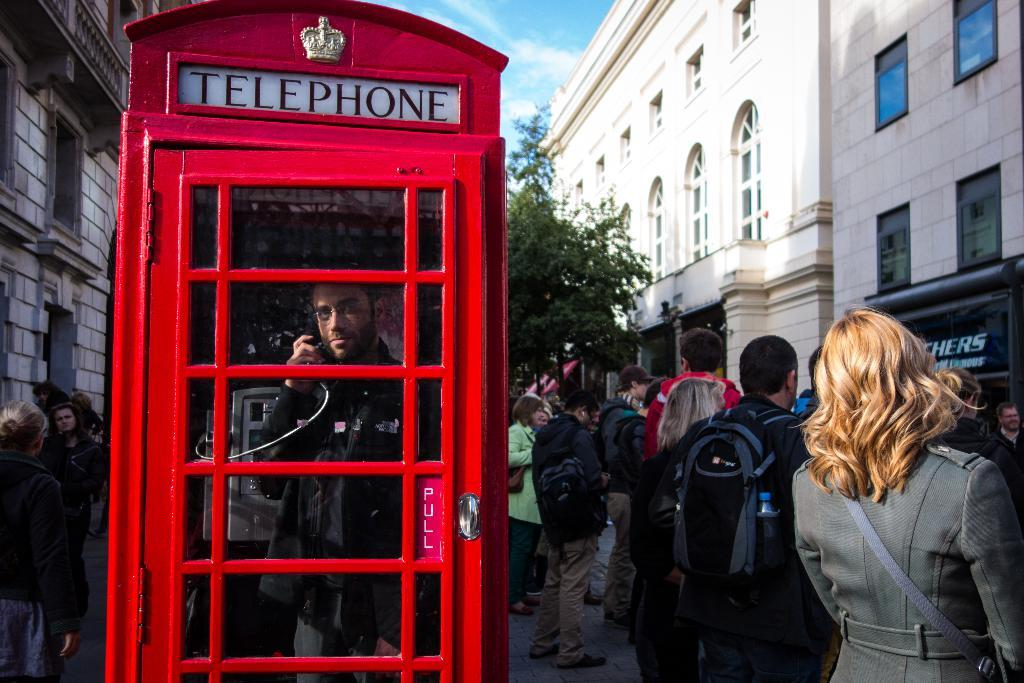<image>
Relay a brief, clear account of the picture shown. On a crowded street, a man talks on the phone inside a red booth labeled TELEPHONE. 